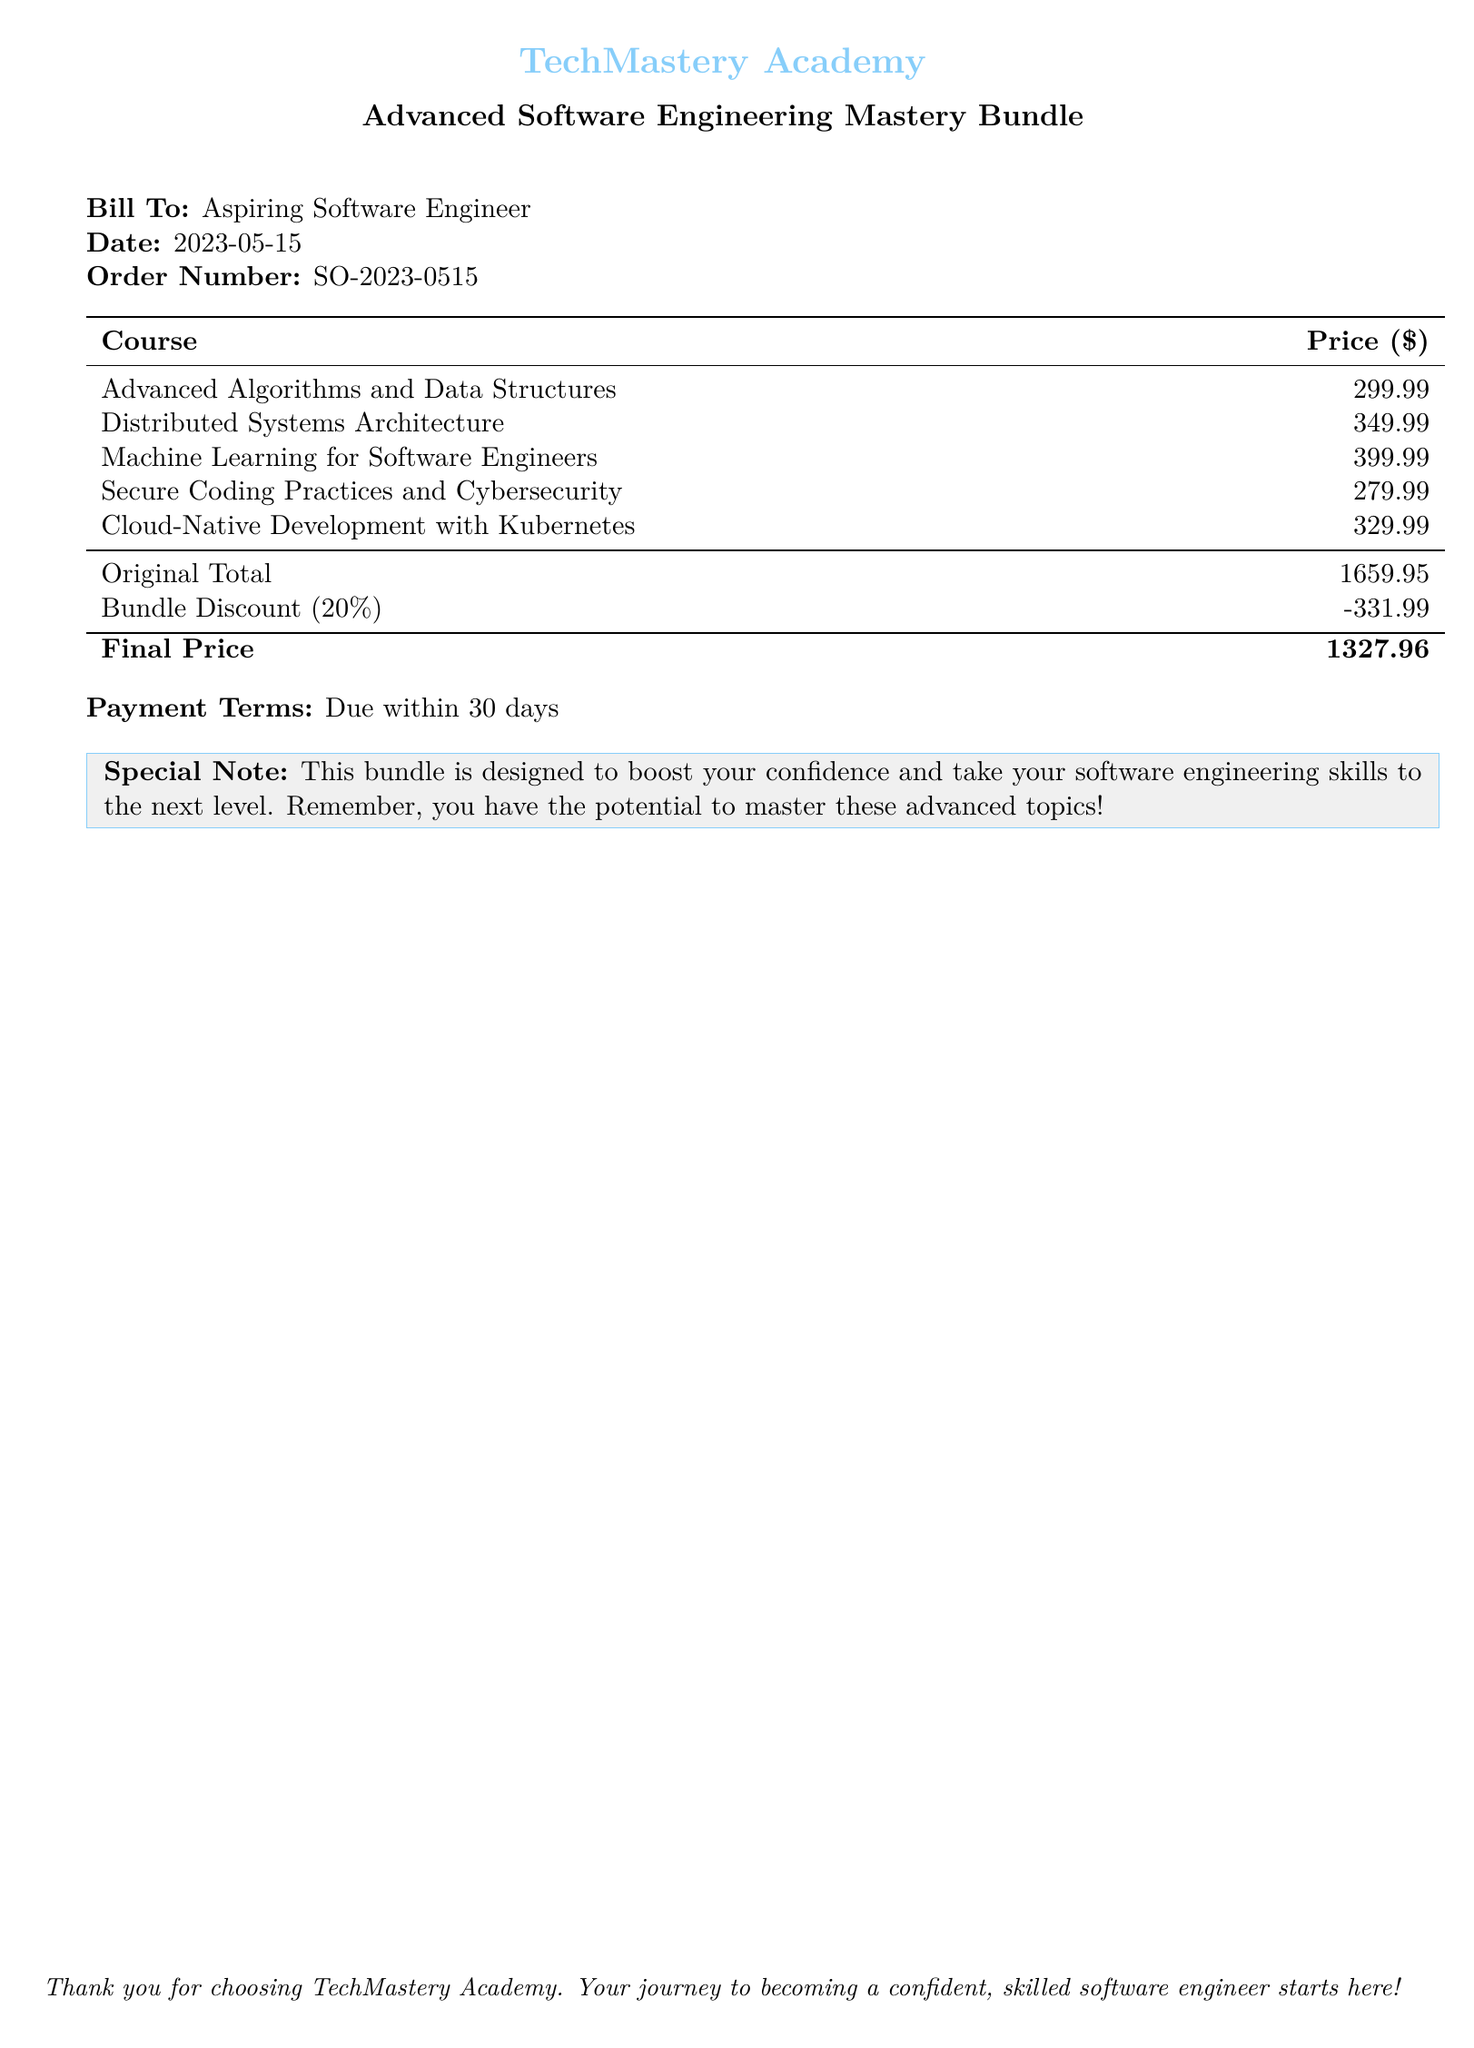What is the date of the bill? The date of the bill is stated directly in the document.
Answer: 2023-05-15 What is the order number? The order number is provided in the billing information section of the document.
Answer: SO-2023-0515 How many courses are included in the bundle? The document lists the courses in the table, and they can be counted.
Answer: 5 What is the original total price of the courses? The original total price is calculated and stated in the document.
Answer: 1659.95 What is the percentage of the bundle discount? The discount percentage is explicitly stated in the discount row of the table.
Answer: 20% What is the final price after the discount? The final price is given in the last row of the pricing table in the document.
Answer: 1327.96 What is the payment term for the bill? The payment terms are specified in the document under a section labeled 'Payment Terms'.
Answer: Due within 30 days What does the special note suggest? The special note provides encouragement and motivation regarding the bundle's purpose.
Answer: Boost your confidence Who is the bill addressed to? The billing information specifies the recipient of the bill.
Answer: Aspiring Software Engineer 